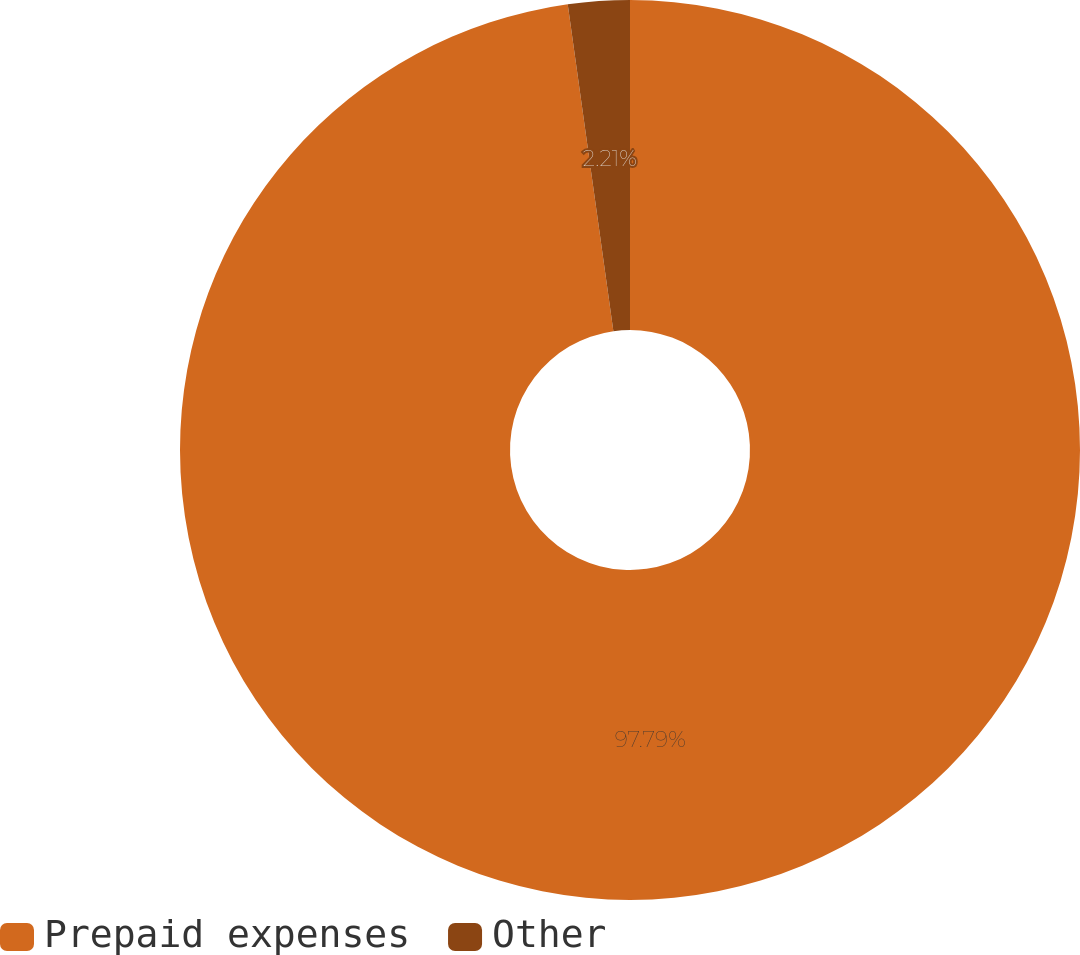<chart> <loc_0><loc_0><loc_500><loc_500><pie_chart><fcel>Prepaid expenses<fcel>Other<nl><fcel>97.79%<fcel>2.21%<nl></chart> 